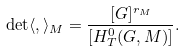Convert formula to latex. <formula><loc_0><loc_0><loc_500><loc_500>\det \langle , \rangle _ { M } = \frac { [ G ] ^ { r _ { M } } } { [ H _ { T } ^ { 0 } ( G , M ) ] } .</formula> 